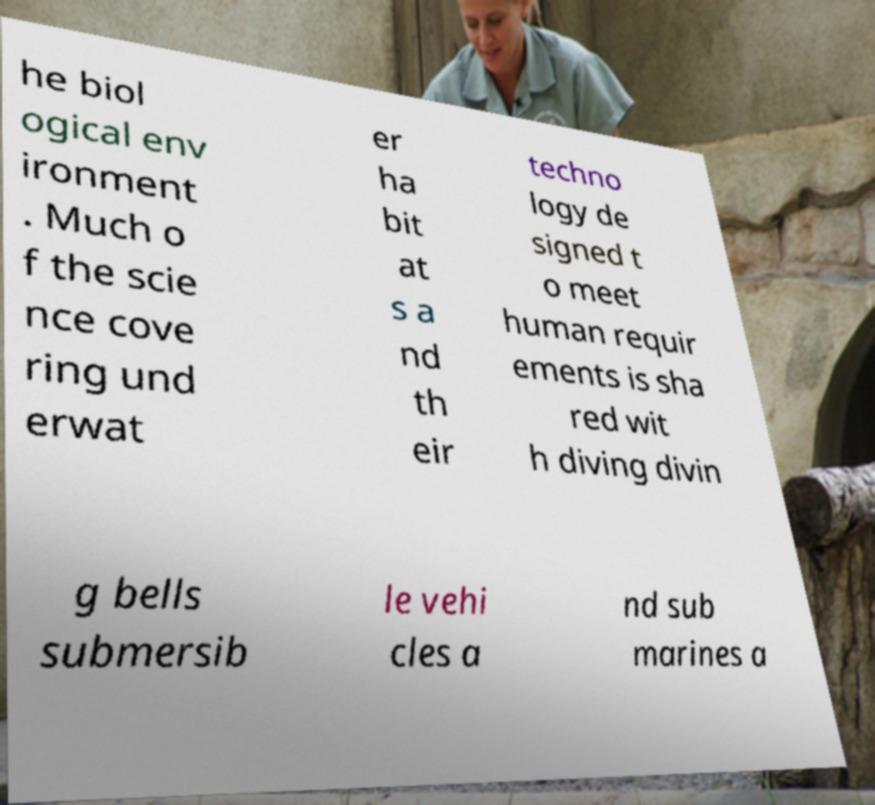For documentation purposes, I need the text within this image transcribed. Could you provide that? he biol ogical env ironment . Much o f the scie nce cove ring und erwat er ha bit at s a nd th eir techno logy de signed t o meet human requir ements is sha red wit h diving divin g bells submersib le vehi cles a nd sub marines a 